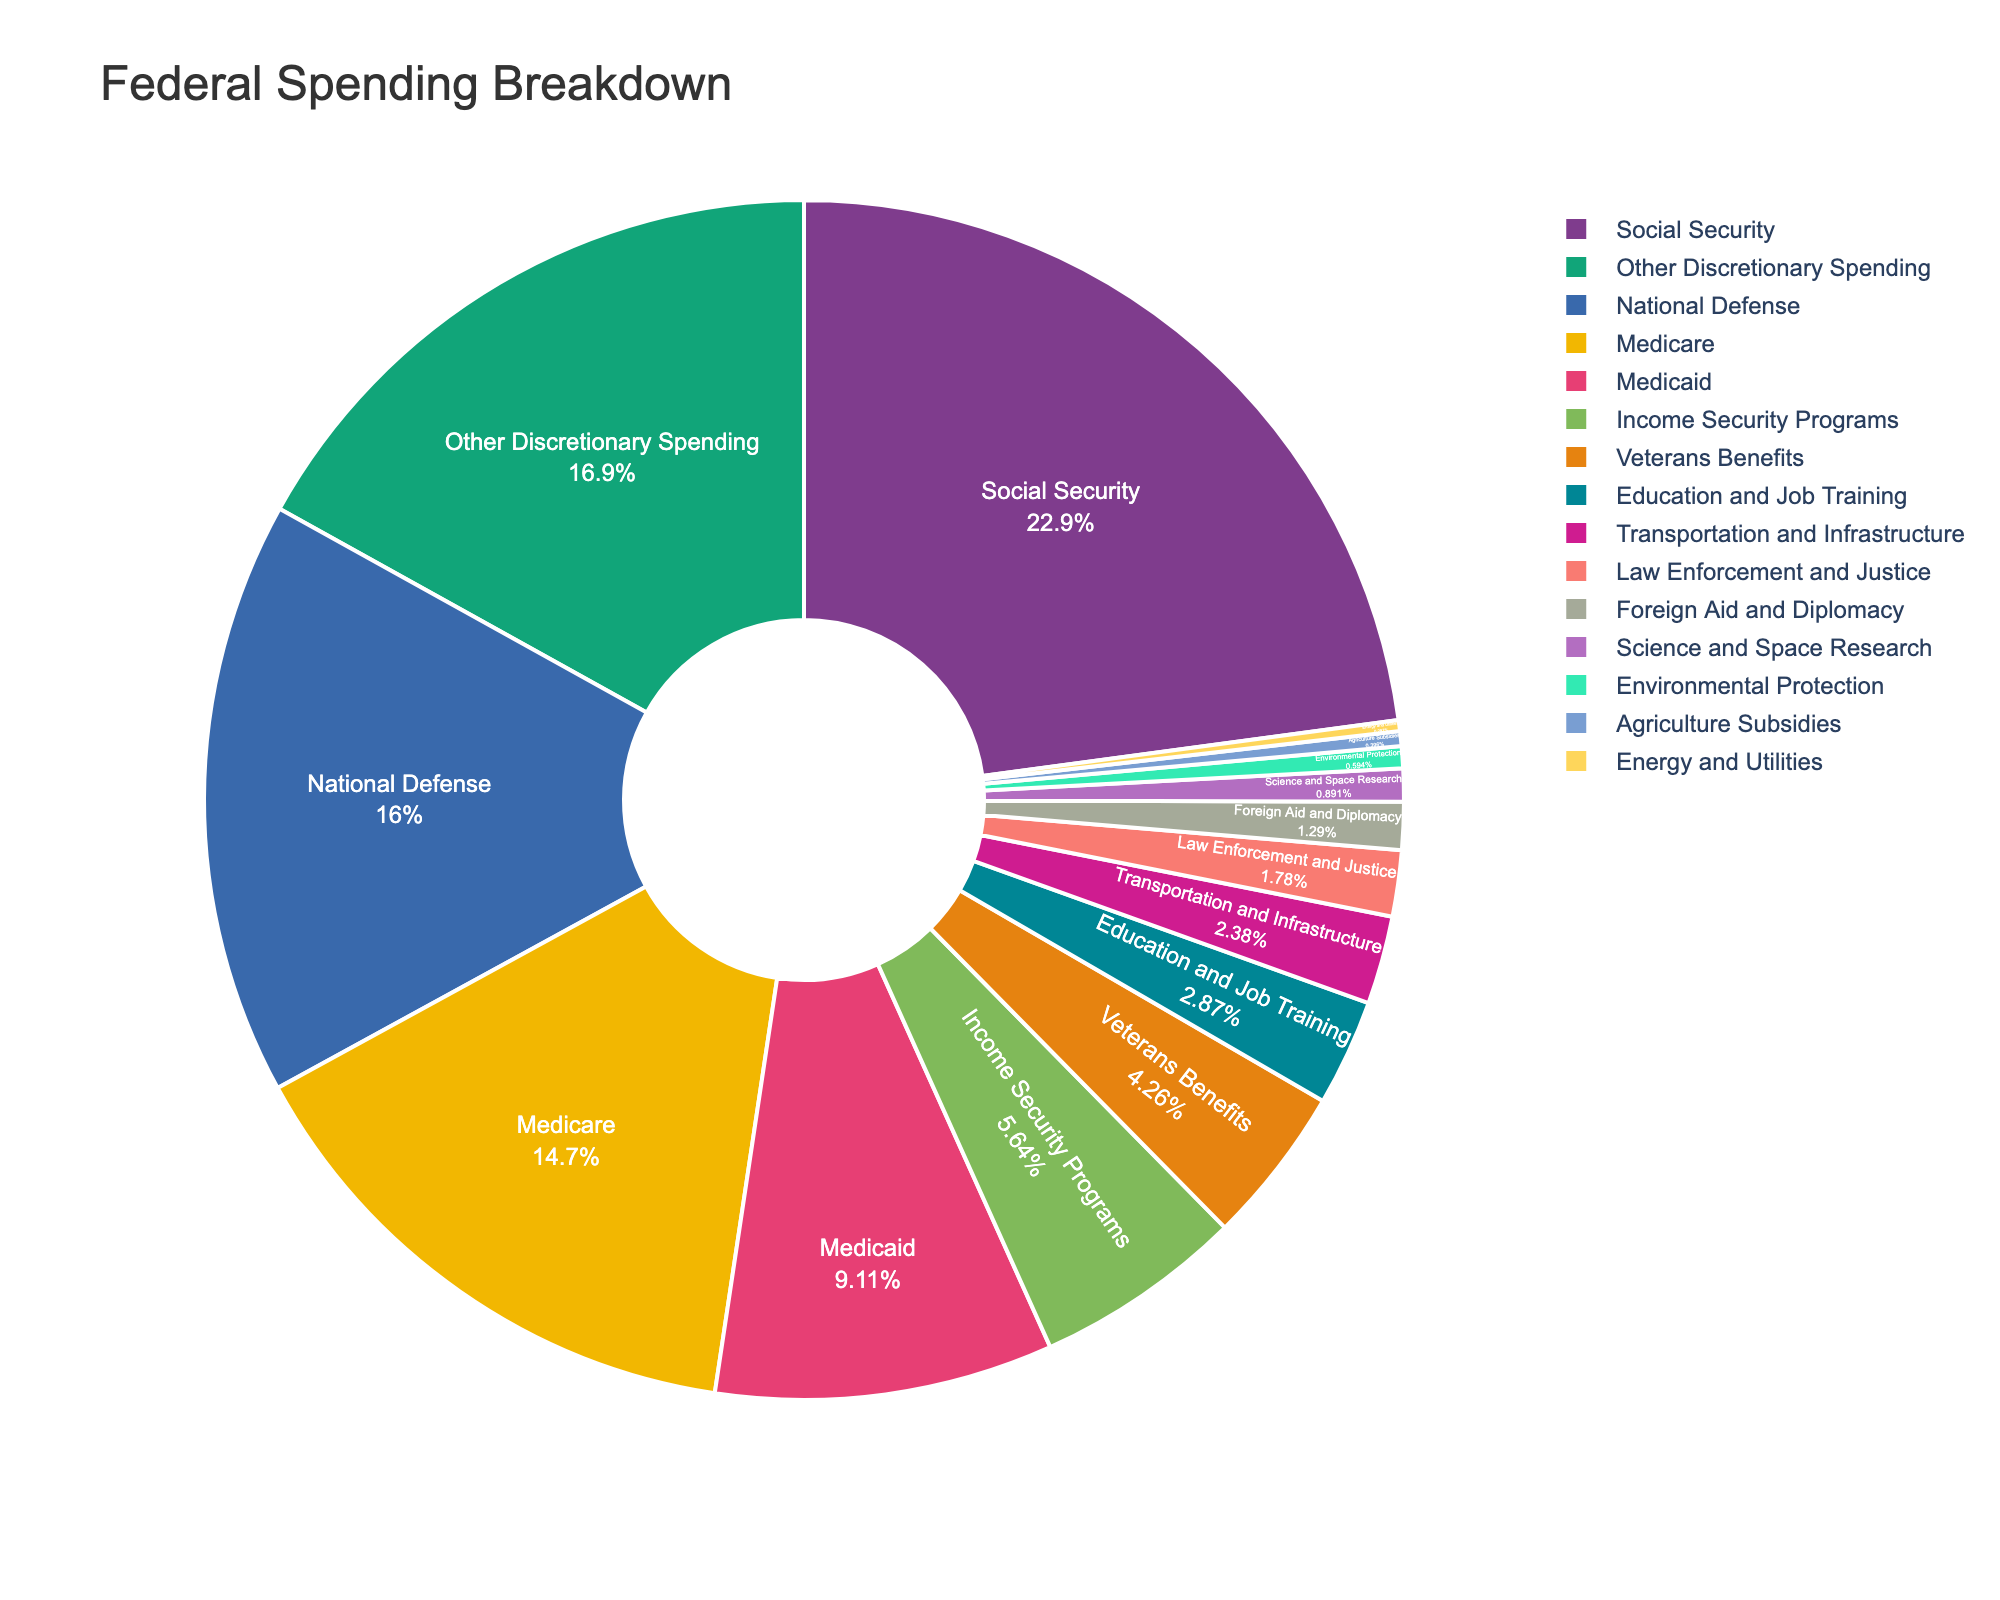What category constitutes the largest percentage of federal spending? By looking at the pie chart, the category with the largest slice represents the highest percentage.
Answer: Social Security What is the combined percentage of federal spending on National Defense and Medicare? Add the percentages of National Defense (16.2%) and Medicare (14.8%): 16.2 + 14.8 = 31.
Answer: 31% How does spending on Education and Job Training compare to spending on Environmental Protection? By comparing the slices, Education and Job Training (2.9%) has a larger percentage than Environmental Protection (0.6%).
Answer: Education and Job Training has a higher percentage If you sum the spending on Social Security, Medicare, and Medicaid, what percentage of federal spending do these categories represent? Add the percentages of Social Security (23.1%), Medicare (14.8%), and Medicaid (9.2%): 23.1 + 14.8 + 9.2 = 47.1.
Answer: 47.1% Which category has the smallest percentage of federal spending and what is it? Look for the smallest slice, which represents the category with the lowest percentage.
Answer: Energy and Utilities, 0.3% Is the percentage of spending on Foreign Aid and Diplomacy higher than on Law Enforcement and Justice? Compare the percentages: Foreign Aid and Diplomacy (1.3%) versus Law Enforcement and Justice (1.8%).
Answer: No What two categories have a combined percentage closest to 5%? By evaluating the chart, the combination of percentages that sum closest to 5% are Agriculture Subsidies (0.4%) and Science and Space Research (0.9%); however, a closer match is Income Security Programs (5.7%). The most precise combination would be to select categories manually until the best pair is found.
Answer: Education and Job Training (2.9%) and Transportation and Infrastructure (2.4%) What is the visual difference between the categories of National Defense and Other Discretionary Spending? The size of the slices shows the visual difference; National Defense (16.2%) has a slightly smaller slice compared to Other Discretionary Spending (17.1%).
Answer: Other Discretionary Spending is slightly larger Which is bigger: the slice for Health-related programs (Medicare and Medicaid combined) or the slice for National Defense? Combine Medicare (14.8%) and Medicaid (9.2%) to get 24, then compare it to National Defense's 16.2% slice.
Answer: Health-related programs How does spending on Veterans Benefits compare to spending on Foreign Aid and Diplomacy and Environmental Protection combined? Add Foreign Aid and Diplomacy (1.3%) and Environmental Protection (0.6%) to get 1.9%, and compare it to Veterans Benefits (4.3%).
Answer: Veterans Benefits is higher 